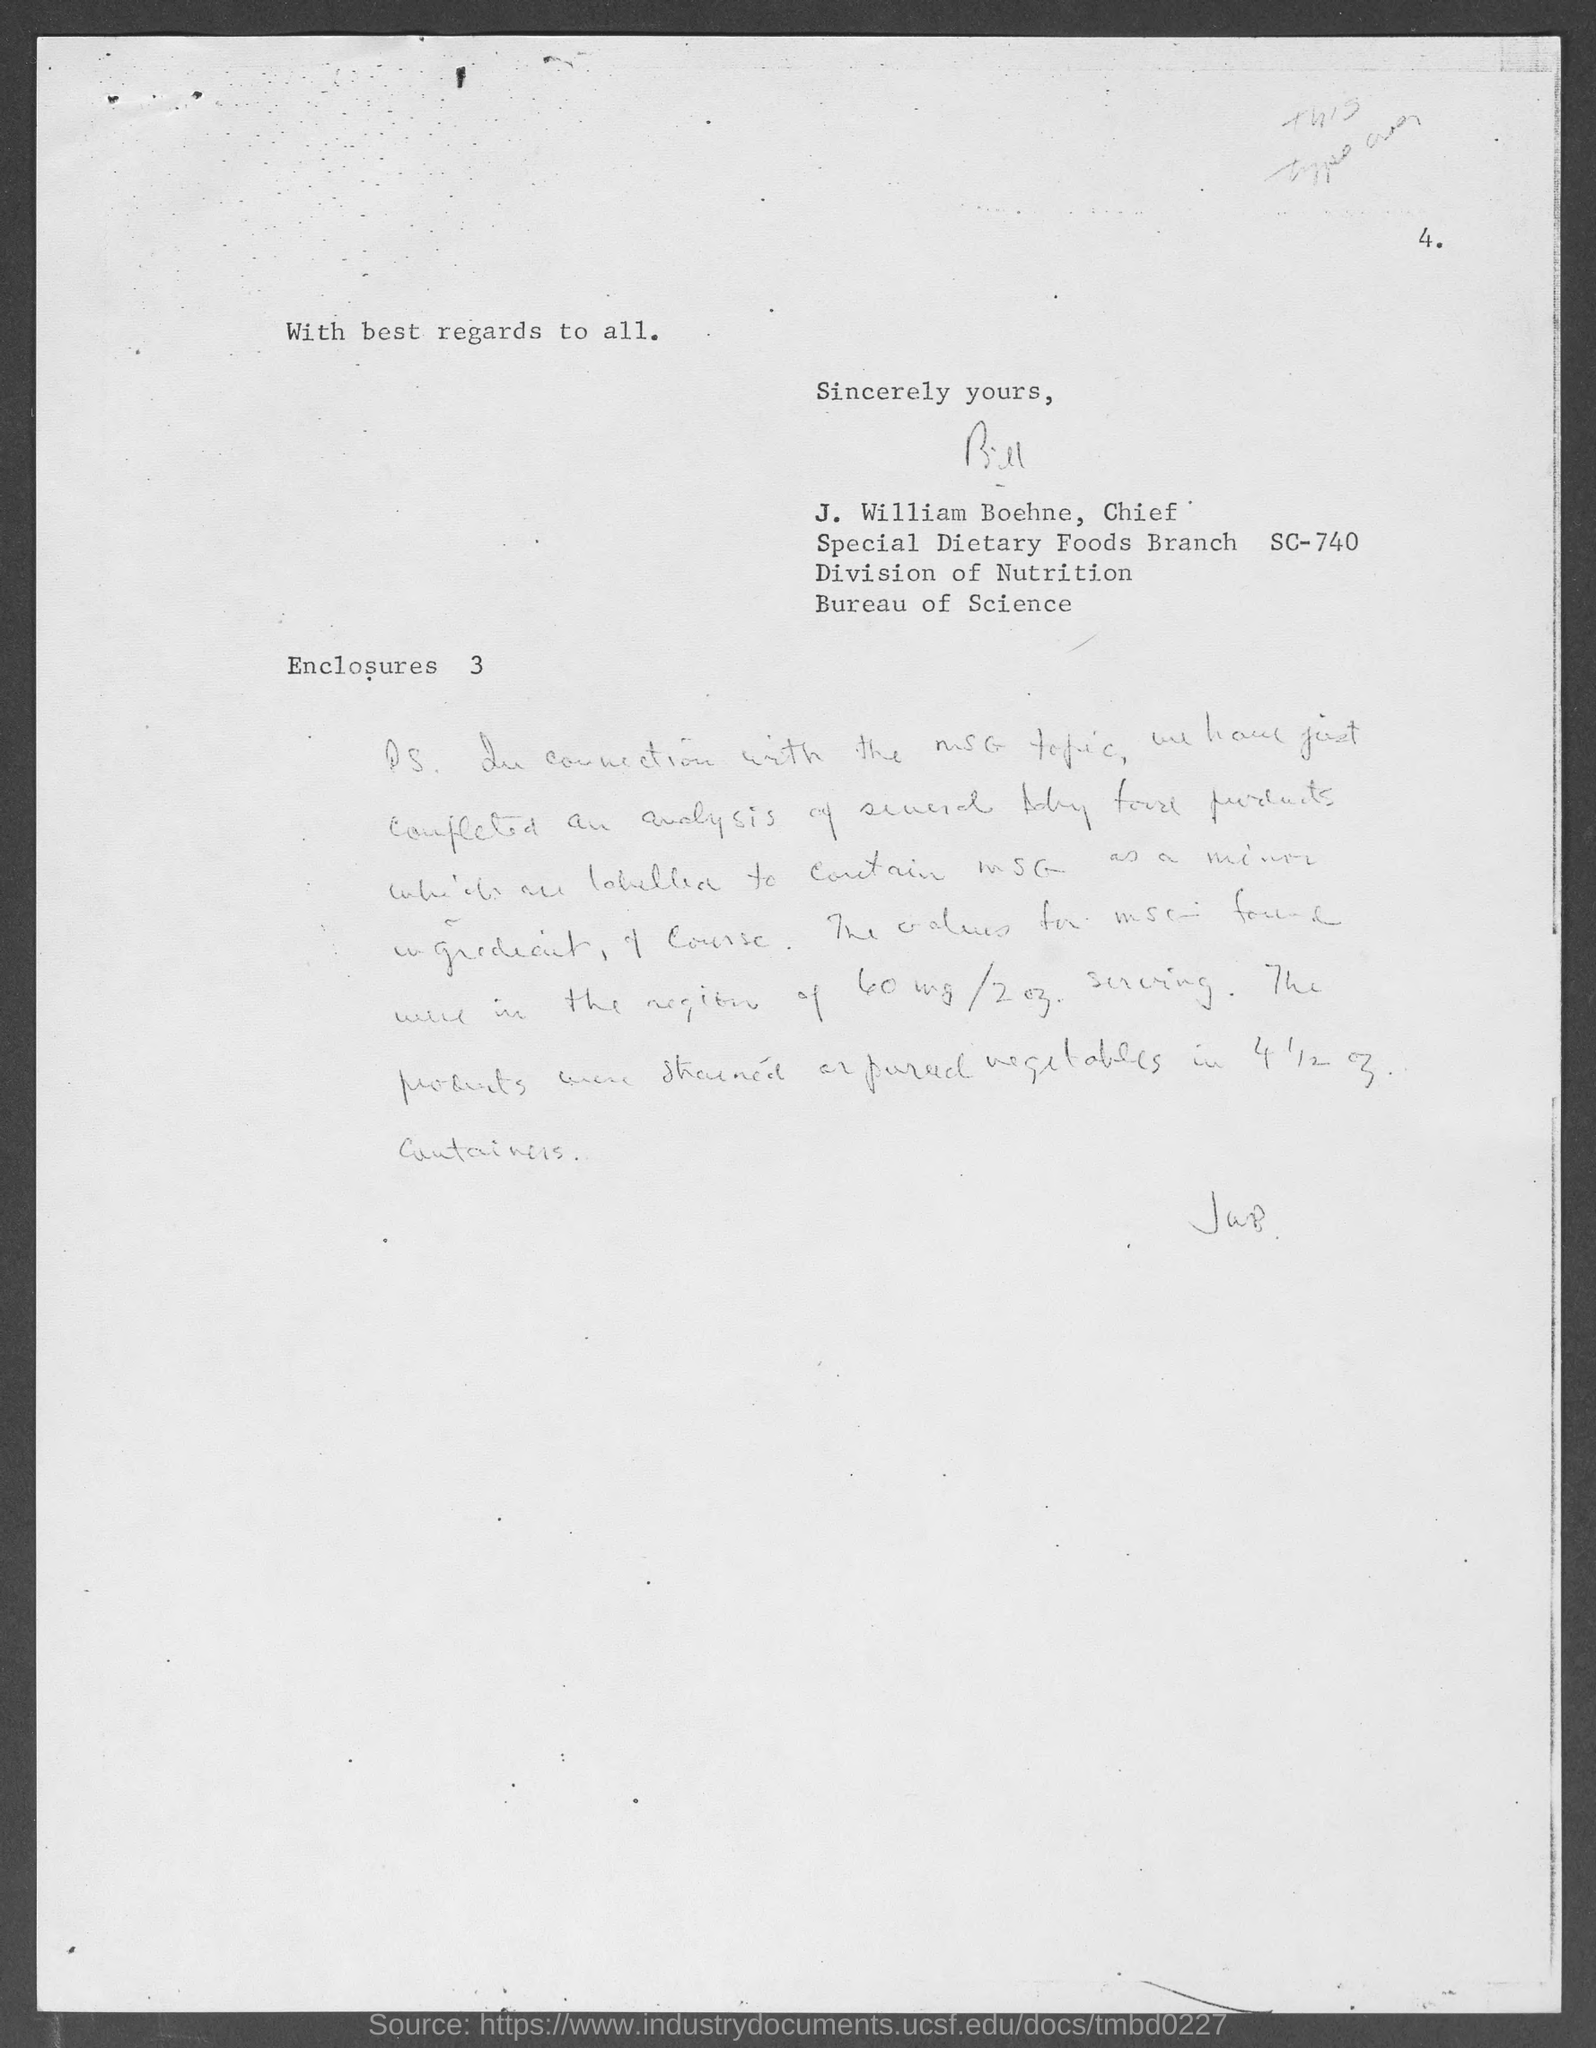Give some essential details in this illustration. J. William Boehne is the chief of the Special Dietary Foods Branch SC-740 in the Division of Nutrition of the Bureau of Science. 